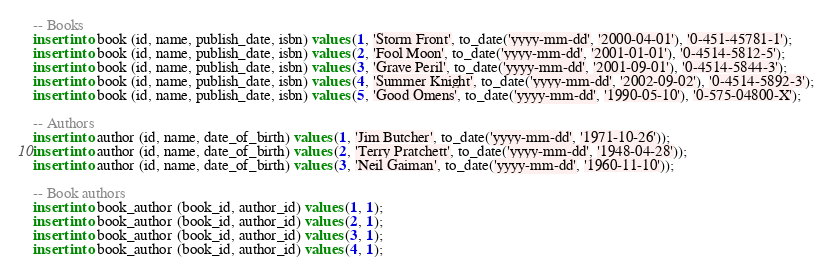<code> <loc_0><loc_0><loc_500><loc_500><_SQL_>-- Books
insert into book (id, name, publish_date, isbn) values (1, 'Storm Front', to_date('yyyy-mm-dd', '2000-04-01'), '0-451-45781-1');
insert into book (id, name, publish_date, isbn) values (2, 'Fool Moon', to_date('yyyy-mm-dd', '2001-01-01'), '0-4514-5812-5');
insert into book (id, name, publish_date, isbn) values (3, 'Grave Peril', to_date('yyyy-mm-dd', '2001-09-01'), '0-4514-5844-3');
insert into book (id, name, publish_date, isbn) values (4, 'Summer Knight', to_date('yyyy-mm-dd', '2002-09-02'), '0-4514-5892-3');
insert into book (id, name, publish_date, isbn) values (5, 'Good Omens', to_date('yyyy-mm-dd', '1990-05-10'), '0-575-04800-X');

-- Authors
insert into author (id, name, date_of_birth) values (1, 'Jim Butcher', to_date('yyyy-mm-dd', '1971-10-26'));
insert into author (id, name, date_of_birth) values (2, 'Terry Pratchett', to_date('yyyy-mm-dd', '1948-04-28'));
insert into author (id, name, date_of_birth) values (3, 'Neil Gaiman', to_date('yyyy-mm-dd', '1960-11-10'));

-- Book authors
insert into book_author (book_id, author_id) values (1, 1);
insert into book_author (book_id, author_id) values (2, 1);
insert into book_author (book_id, author_id) values (3, 1);
insert into book_author (book_id, author_id) values (4, 1);</code> 